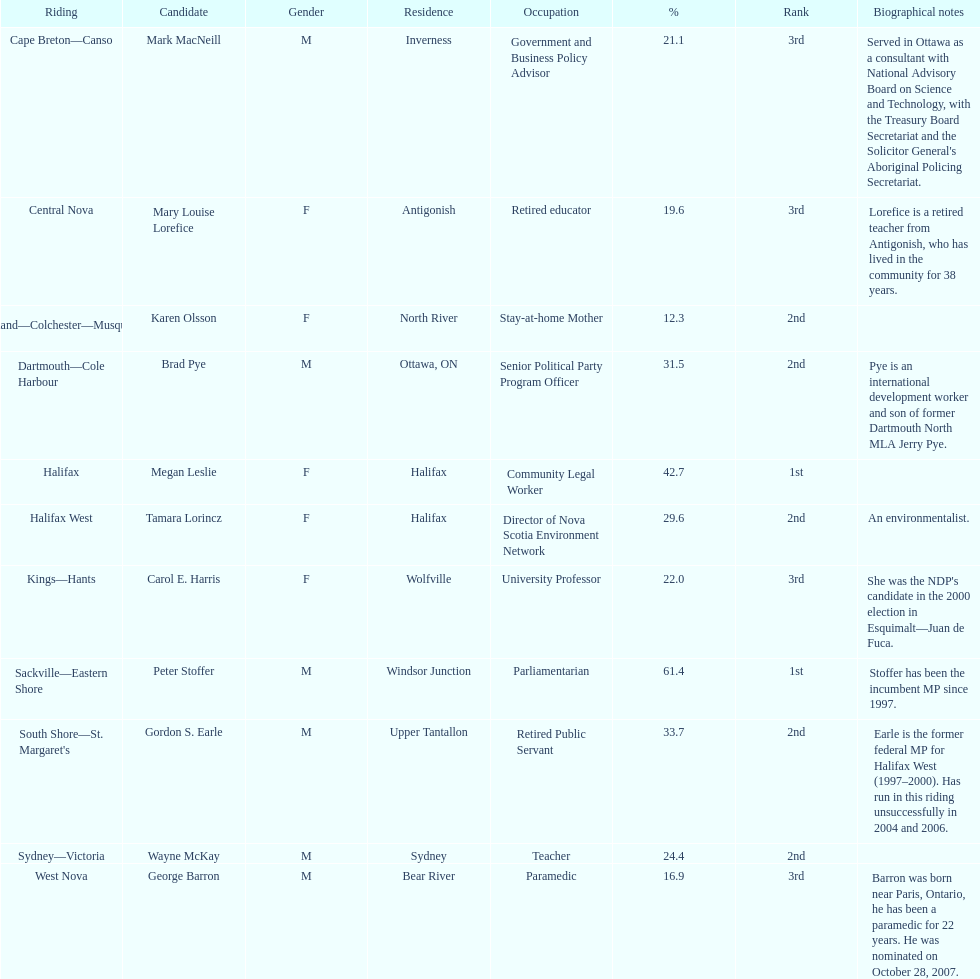How many participants were from halifax? 2. 